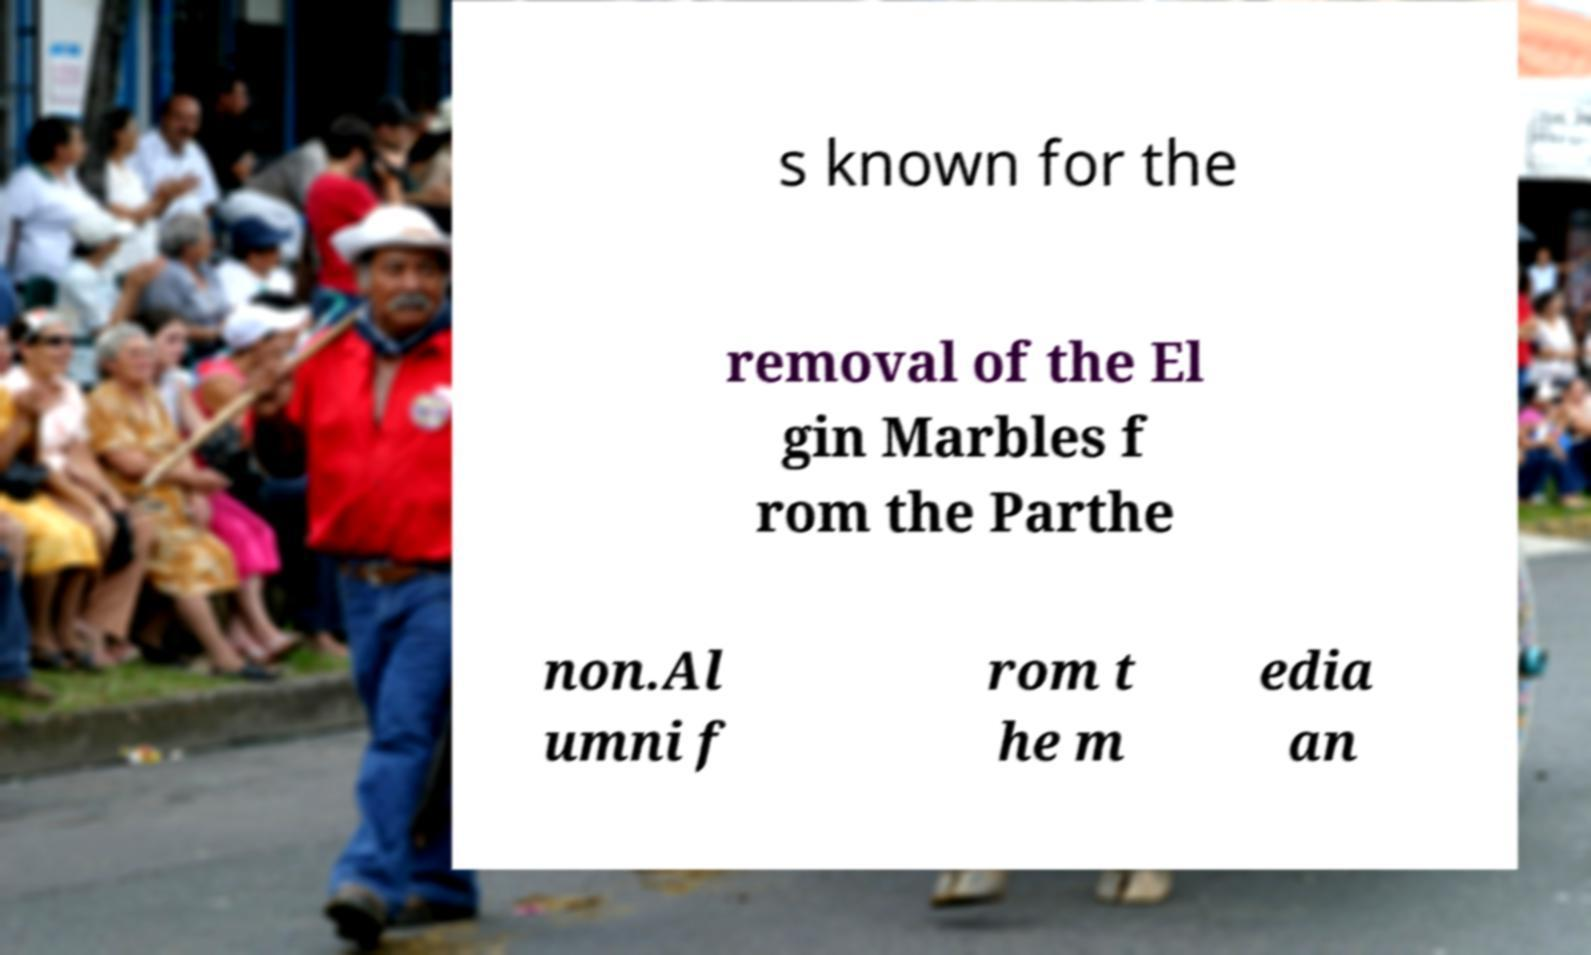There's text embedded in this image that I need extracted. Can you transcribe it verbatim? s known for the removal of the El gin Marbles f rom the Parthe non.Al umni f rom t he m edia an 